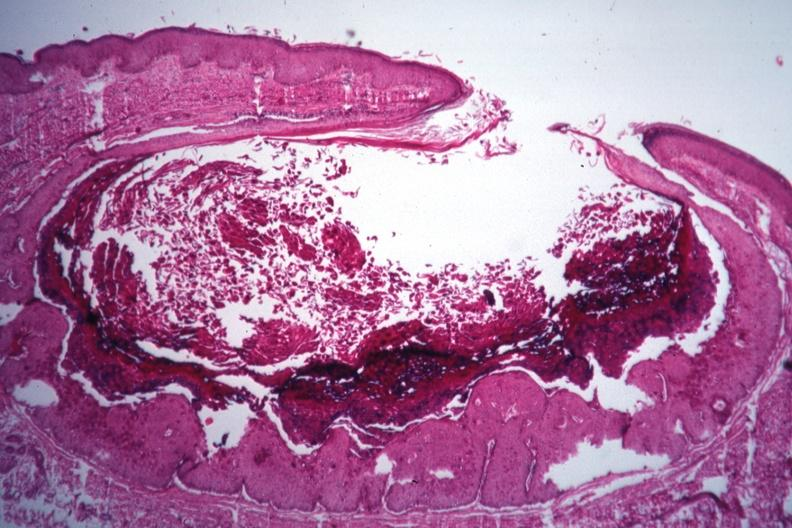s molluscum contagiosum present?
Answer the question using a single word or phrase. Yes 